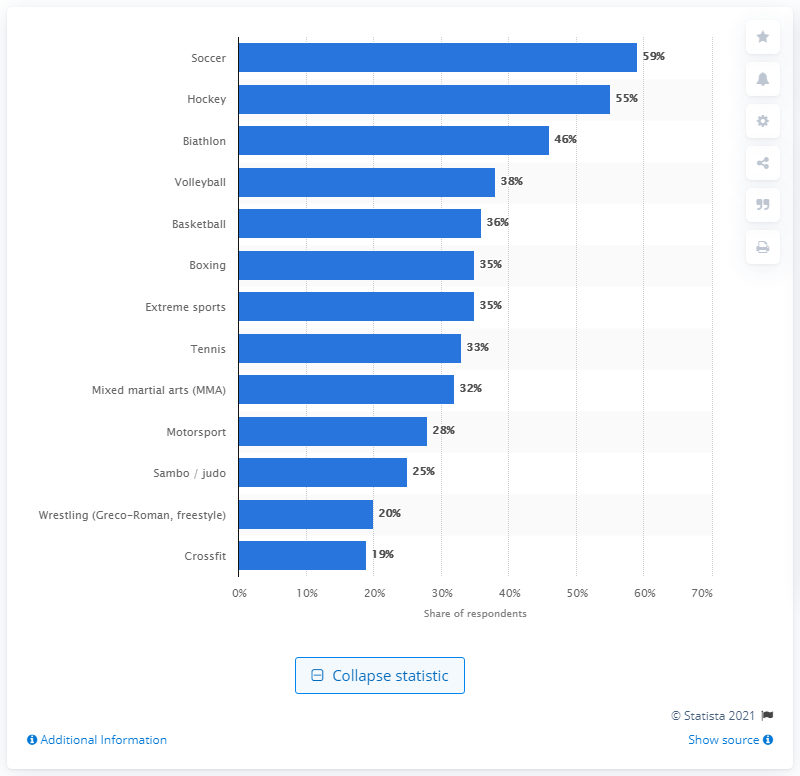Mention a couple of crucial points in this snapshot. The percentage of Russians interested in hockey was 55%. 